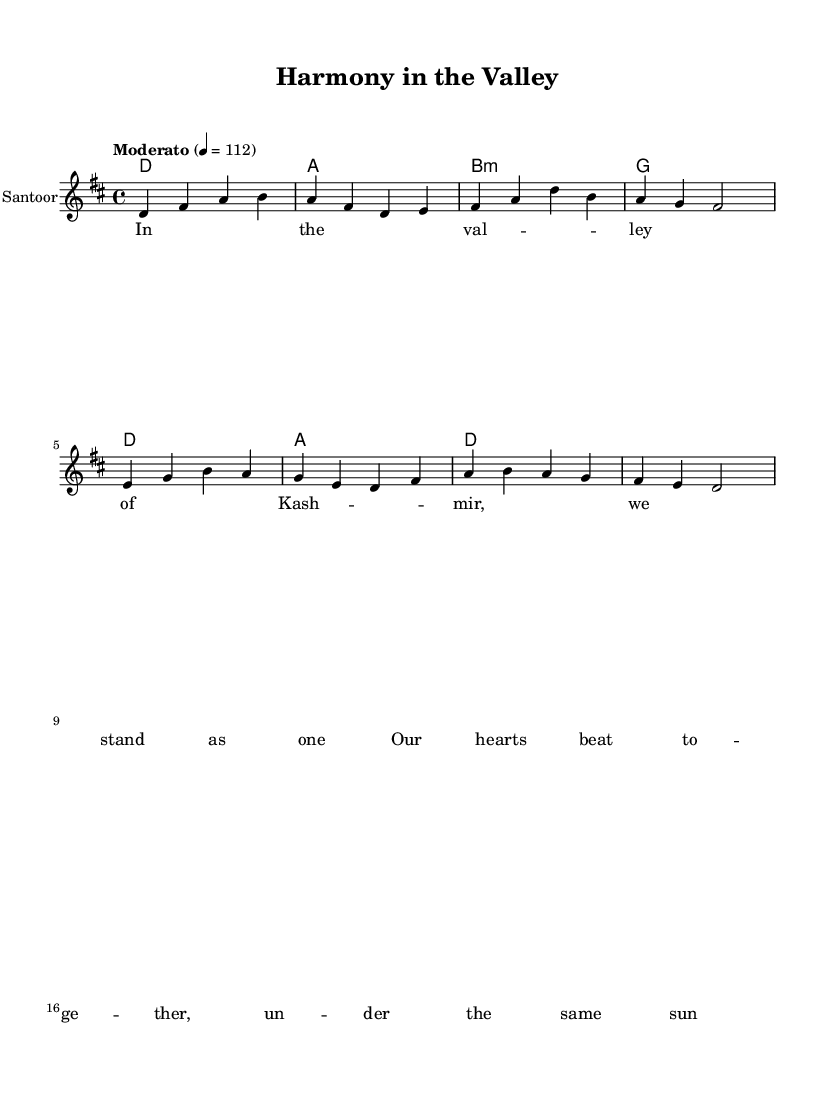What is the key signature of this music? The key signature is D major, which has two sharps (F# and C#). This can be identified from the key signature indicated at the beginning of the staff.
Answer: D major What is the time signature of this piece? The time signature is 4/4, which indicates that there are four beats in each measure and a quarter note receives one beat. This is noted at the beginning of the music, where the time signature is presented.
Answer: 4/4 What is the tempo marking for this score? The tempo marking is "Moderato," which suggests a moderate and comfortable speed. The metronome marking of 112 indicates that there are 112 quarter-note beats per minute.
Answer: Moderato How many measures are in the melody? The melody is comprised of 8 measures, which can be counted by identifying the separation of each group of notes between vertical lines (bar lines) in the sheet music. There are a total of 8 sections divided by these lines.
Answer: 8 measures What instrument is indicated for the melody? The instrument indicated for the melody is the Santoor, which is specified at the beginning of the staff. This informs the performer which instrument should play the written notes.
Answer: Santoor What theme is expressed in the lyrics of this song? The theme expressed in the lyrics focuses on unity and harmony among people in Kashmir, as evident from phrases that suggest togetherness and commonality under a shared sky. The lyrics emphasize standing as one in the valley.
Answer: Unity and harmony What type of chord is used in the third measure of the harmonies? The chord used in the third measure is B minor, which can be identified by recognizing the chord symbol "b:m" that appears in the chord progression for that measure.
Answer: B minor 